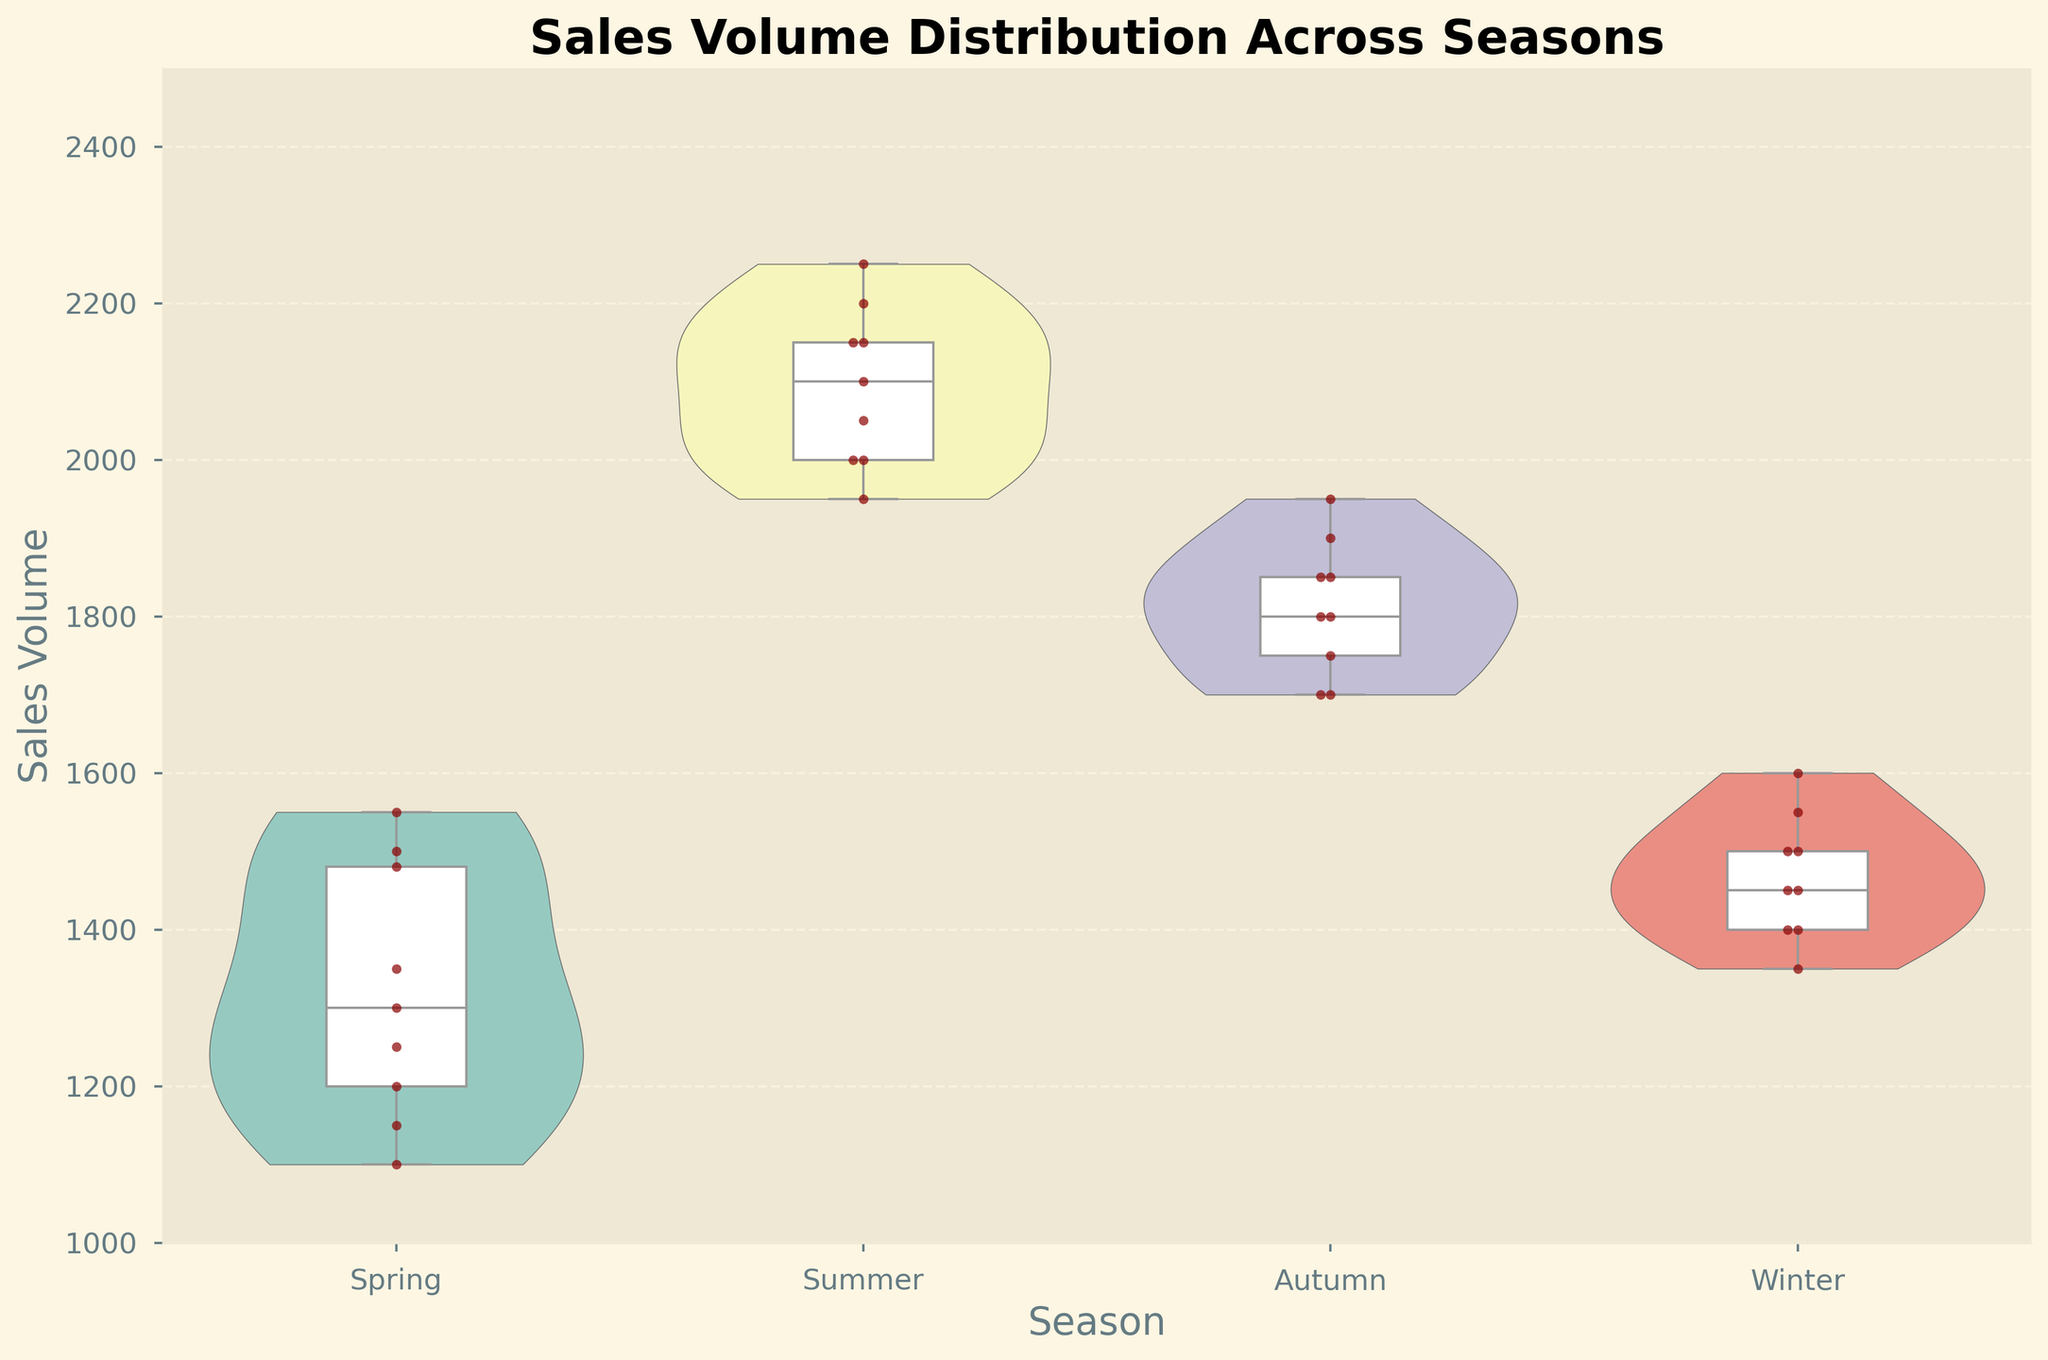Is there a clear seasonal trend in sales volume based on the observed distributions? By examining the shapes and central tendencies in the violin and box plots, we can observe that sales volumes are higher during the Summer and Autumn compared to Spring and Winter. The interquartile range (IQR) is also wider in Summer and Autumn, indicating more variability.
Answer: Yes, sales volumes are higher in Summer and Autumn Which season has the median sales volume closest to 1500? The box plot overlay shows the median line within each season's distribution. For Spring, it's around 1250, for Summer it's above 2000, for Autumn it's around 1850, and for Winter it is near 1500.
Answer: Winter During which season did Store 3 have the highest variation in sales volume? The scatter points in the violin plot for Store 3 show the spread of sales volumes. In Summer, Store 3's sales vary from 2000 to 2150, which is the widest range compared to other seasons.
Answer: Summer What is the approximate range of sales volumes for Store 2 during Autumn? The violins give an idea of the spread, and the box plot markers reinforce this range. Store 2's sales volumes in Autumn range between 1850 and 1950.
Answer: 1850 to 1950 Are the sales volumes consistent for all stores during Spring? Viewing the width and spread of the violins, Store 2 shows a wider distribution indicating more variability compared to the other stores whose sales volumes are more consistent (narrower).
Answer: No, Store 2 is more variable Which season exhibits the least variability in overall sales volume? The violin plot for Winter is the narrowest compared to other seasons, indicating less variability in sales volume across all stores.
Answer: Winter Do any stores show overlapping sales volumes between Summer and Autumn? By comparing the ranges visually from the violins and points: Store 3's Summer range overlaps slightly with its Autumn range at the high end around 2000-2100.
Answer: Yes, Store 3 In which seasons are the upper quartiles of sales volumes highest? Observing the box plots, both Summer and Autumn show upper quartile values above 2000 for multiple stores.
Answer: Summer and Autumn How do the median sales volumes for Store 1 change across the seasons? Tracing Store 1's median lines in each box plot: Spring (~1150), Summer (~2000), Autumn (~1800), and Winter (~1400), shows a general rise in Summer and Autumn, with drops in Spring and Winter.
Answer: Increase in Summer, Autumn; Decrease in Spring, Winter 